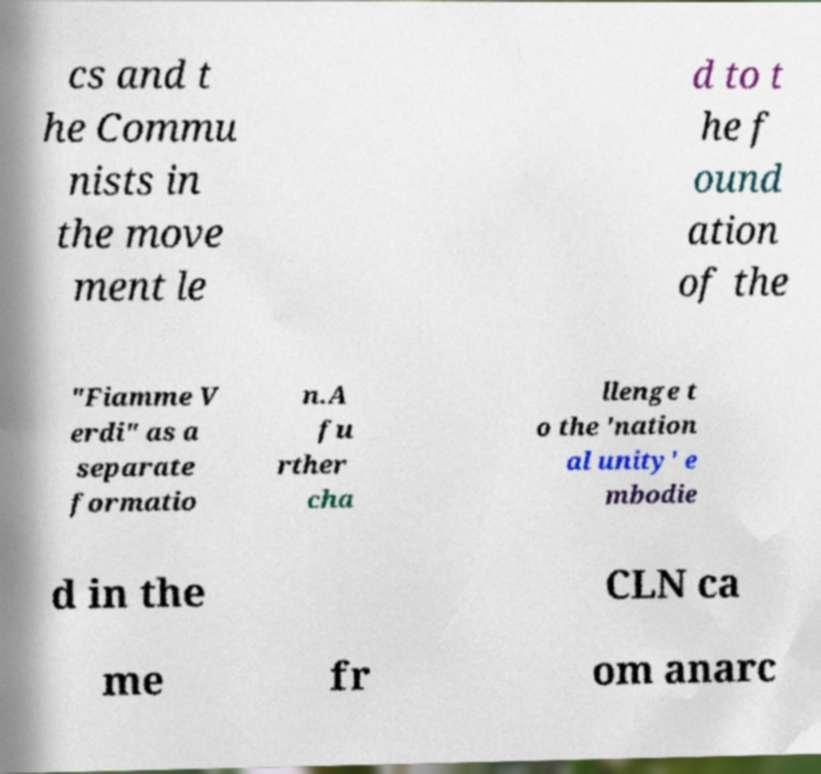I need the written content from this picture converted into text. Can you do that? cs and t he Commu nists in the move ment le d to t he f ound ation of the "Fiamme V erdi" as a separate formatio n.A fu rther cha llenge t o the 'nation al unity' e mbodie d in the CLN ca me fr om anarc 